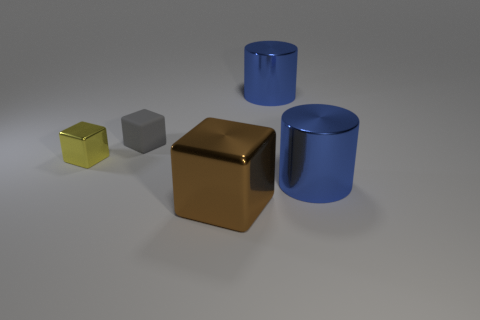Can you tell me which objects in the image have a reflective surface? From the image, it seems that the large golden cube and the two cylinders possess reflective surfaces, as evidenced by the light and surrounding objects reflecting off their exteriors. 